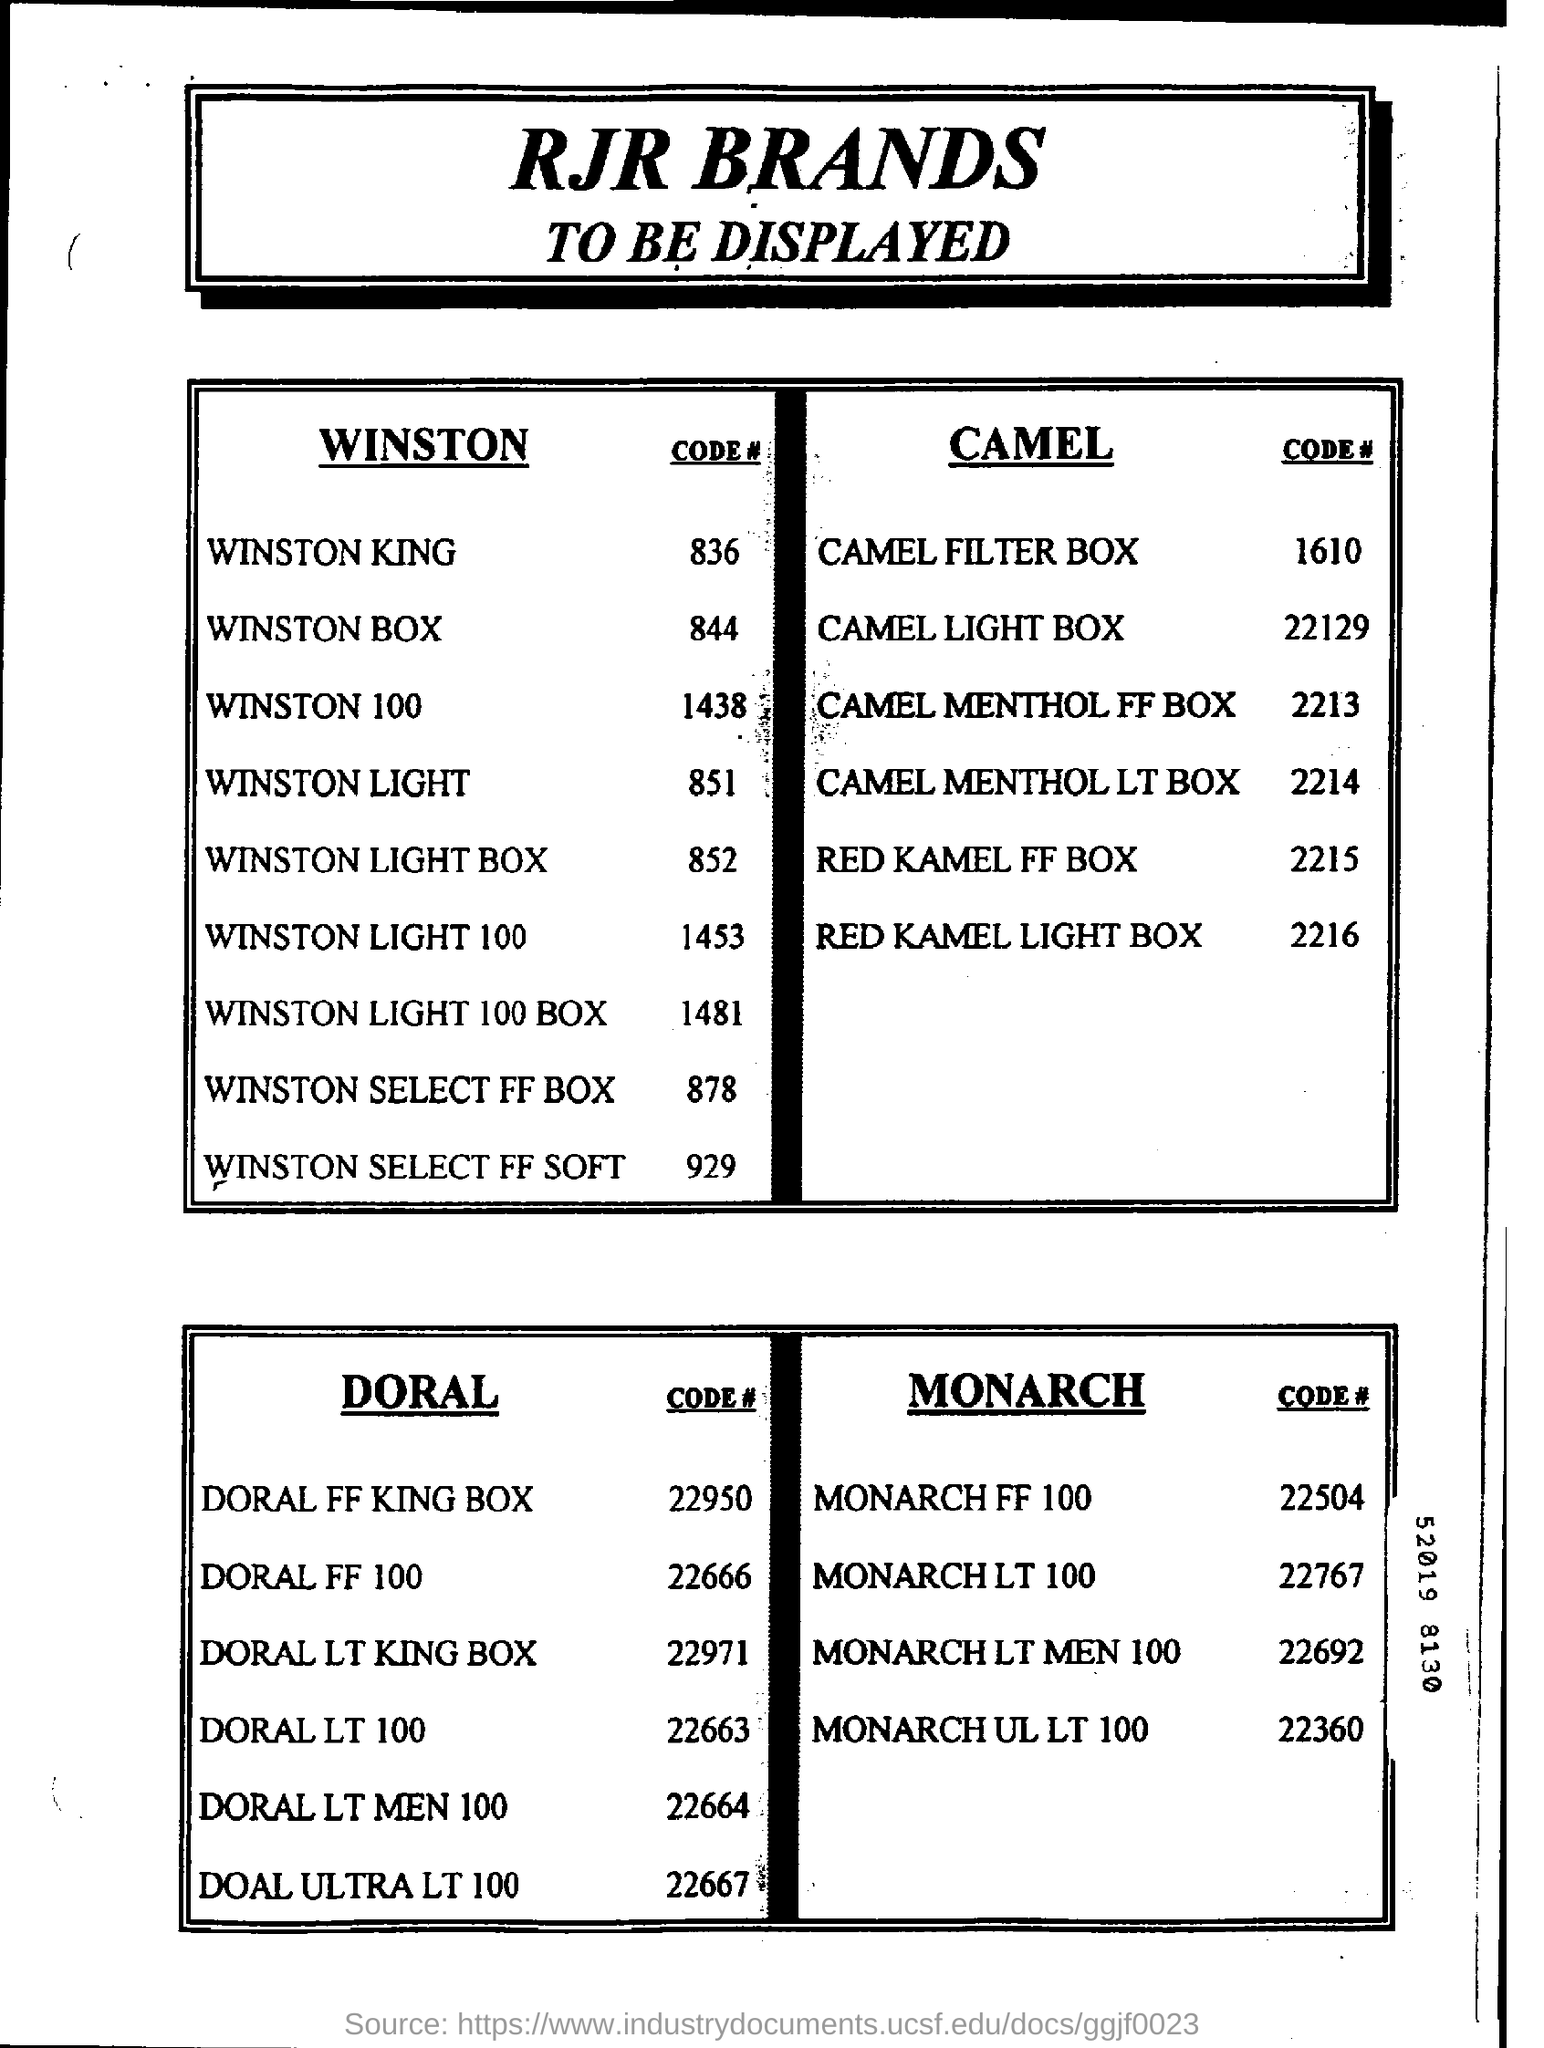Mention a couple of crucial points in this snapshot. The Code of WINSTON 100 is a sequence of numbers that begins with 1438... What is the Code of DORAL LT 100? It is 22663. The code for the WINSTON SELECT FF BOX is 878.... The code for the RED KAMEL LIGHT BOX is 2216... I'm sorry, but the information you've provided is not clear or complete, and I'm unable to understand what you're asking. Could you please provide more context or clarification? 